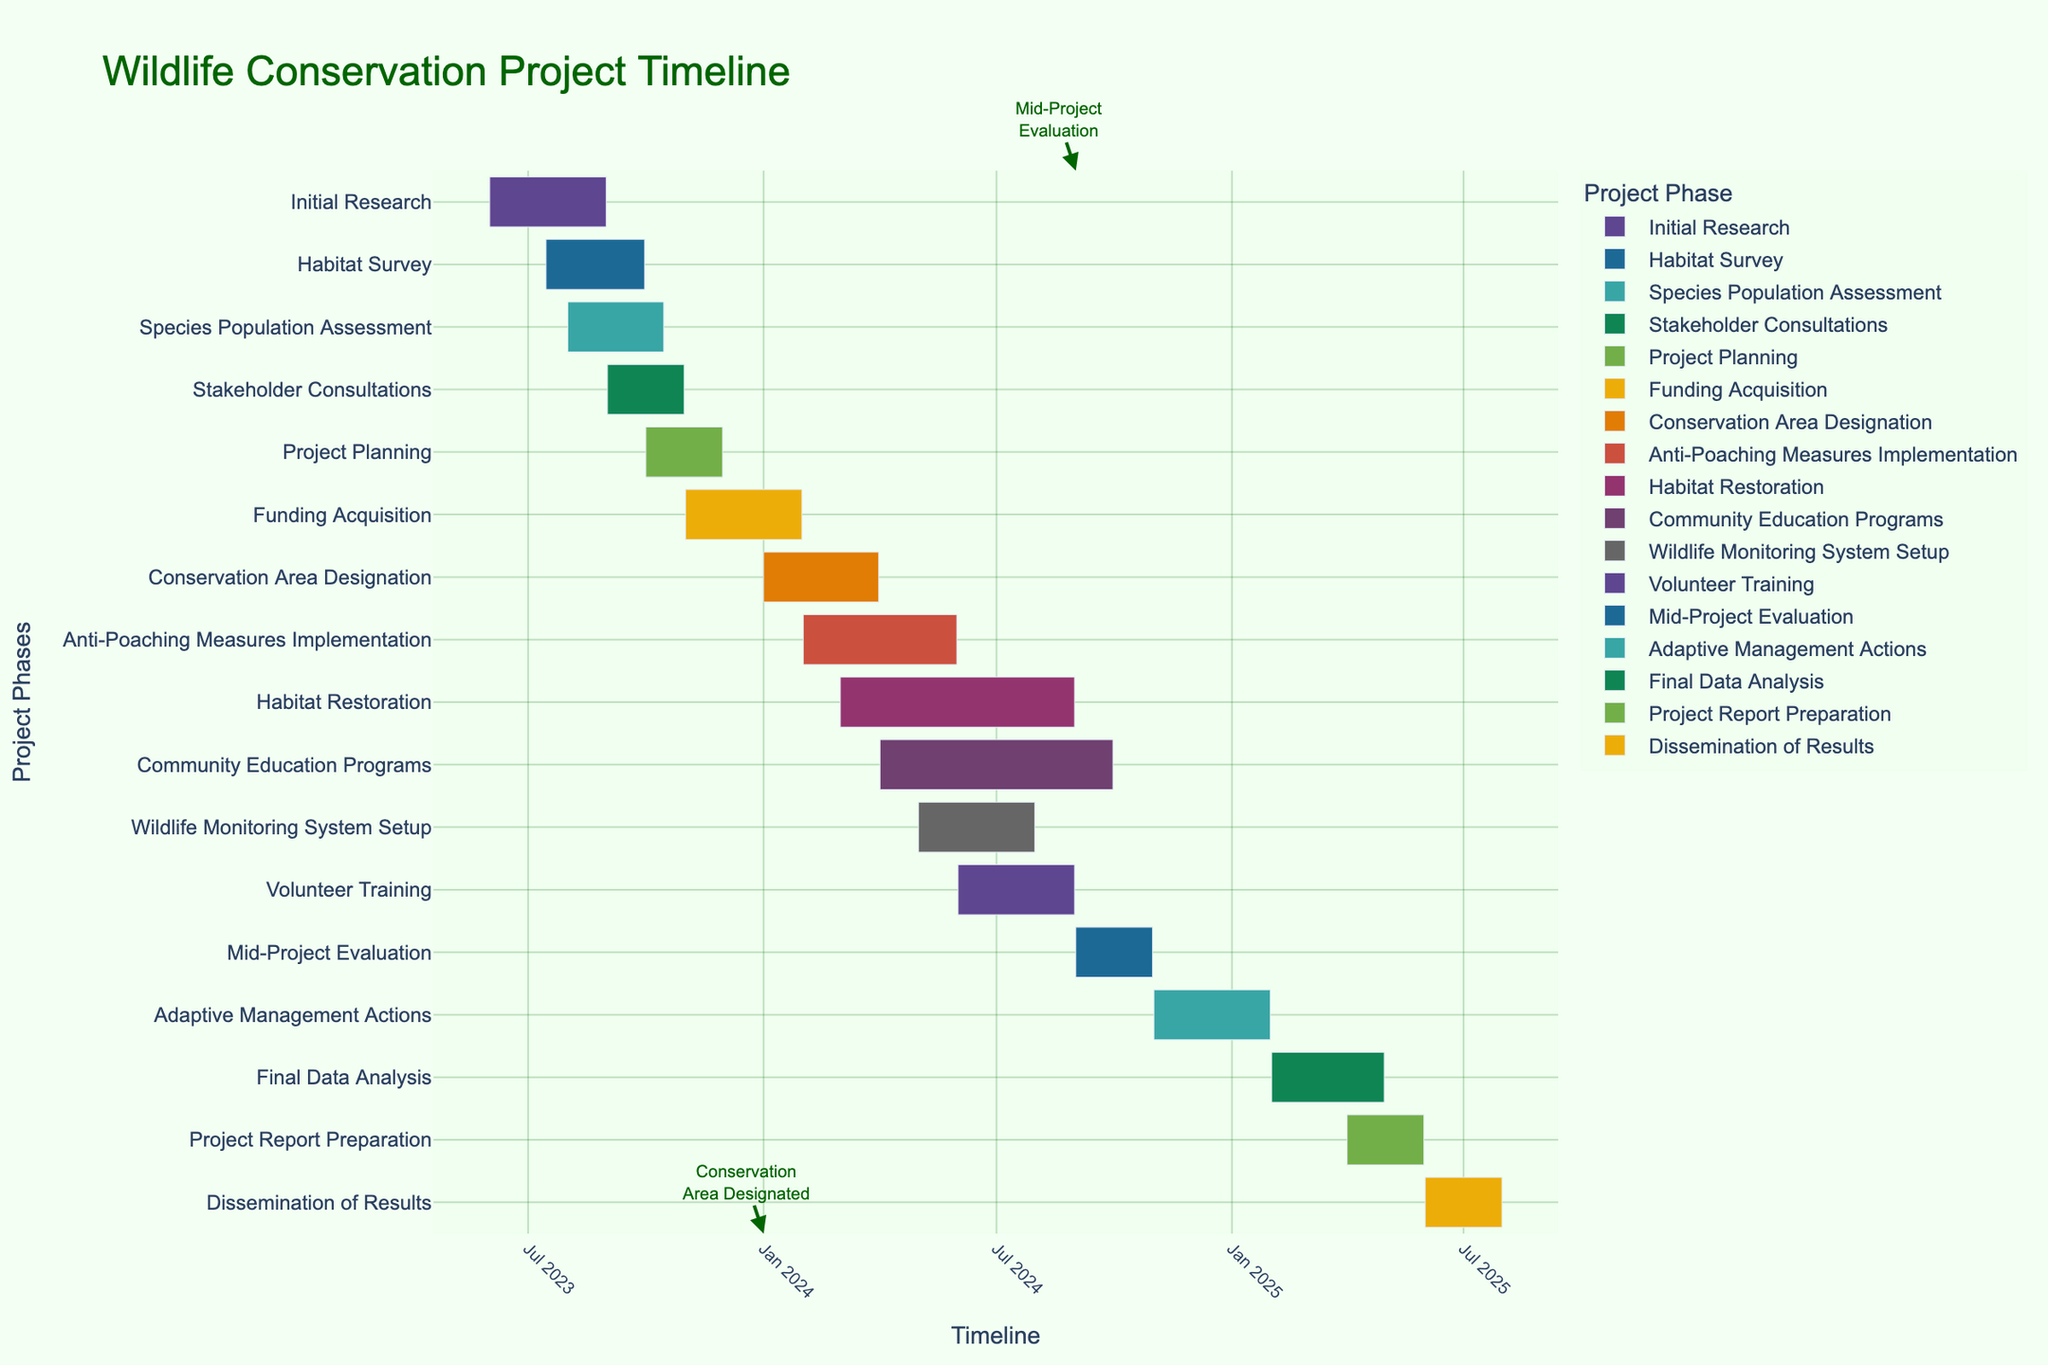What is the title of the Gantt Chart? The title of the chart is usually displayed at the top and provides a summary of the chart's content. In this case, the title should be directly taken from the figure.
Answer: Wildlife Conservation Project Timeline What is the start and end date of the "Initial Research" task? To find this, look for the "Initial Research" task on the y-axis and read the corresponding start and end dates on the x-axis.
Answer: June 1, 2023, to August 31, 2023 Which task has the longest duration? To determine the task with the longest duration, compare the lengths of the bars representing each task. The longest bar will indicate the task with the longest duration.
Answer: Habitat Restoration What is the duration of the "Community Education Programs" task? Find the start and end dates of the "Community Education Programs" task and calculate its duration by subtracting the start date from the end date.
Answer: 6 months Which tasks are scheduled to start in 2024? Identify tasks with start dates in 2024 by looking at the x-axis and locating the tasks within the corresponding timeframe.
Answer: Conservation Area Designation, Anti-Poaching Measures Implementation, Habitat Restoration, Community Education Programs, Wildlife Monitoring System Setup, Volunteer Training, Mid-Project Evaluation, Adaptive Management Actions, Final Data Analysis, Project Report Preparation, Dissemination of Results What is the gap between the end of "Species Population Assessment" and the start of "Project Planning"? Determine the end date of the "Species Population Assessment" and the start date of the "Project Planning" task, then find the time difference between these dates.
Answer: 15 days Which two tasks overlap the most in terms of duration? Observe the tasks that are scheduled to occur concurrently and assess the extent of their overlap by comparing the start and end dates of each pair of tasks.
Answer: Anti-Poaching Measures Implementation and Habitat Restoration How many tasks are involved in the evaluation phase? Look for tasks that include keywords related to evaluation, such as "evaluation," "analysis," or "report preparation," and count them.
Answer: 3 tasks Which tasks have milestones annotated in the figure? Look for annotations denoting important milestones or events within the tasks and identify the corresponding tasks.
Answer: Conservation Area Designation and Mid-Project Evaluation 